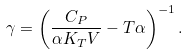Convert formula to latex. <formula><loc_0><loc_0><loc_500><loc_500>\gamma = \left ( \frac { C _ { P } } { \alpha K _ { T } V } - T \alpha \right ) ^ { - 1 } .</formula> 